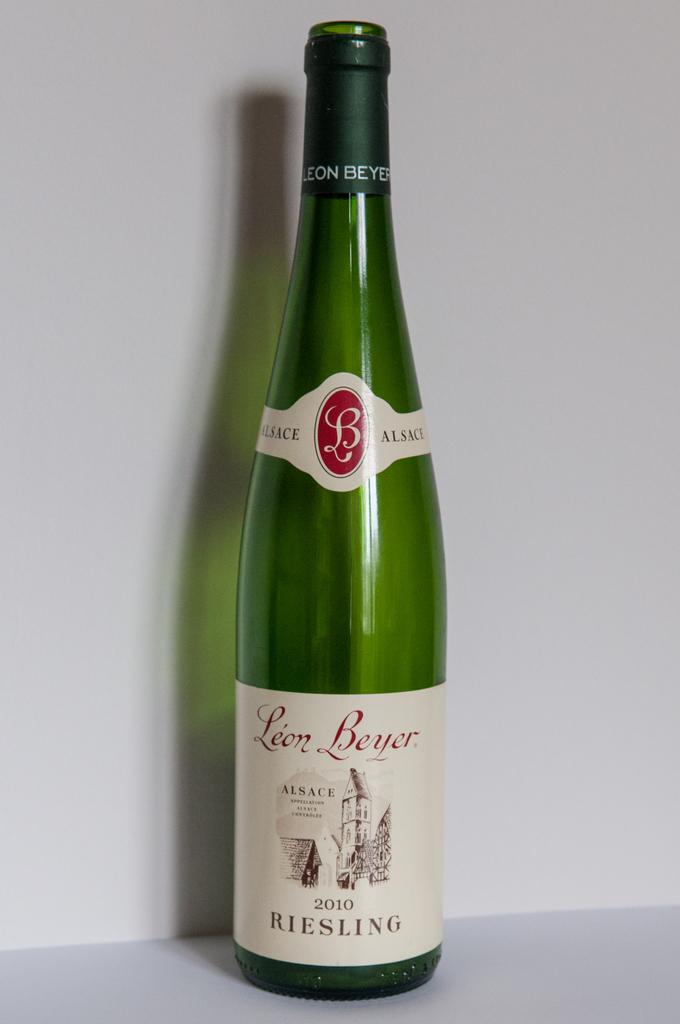Which country was that wine made in?
Keep it short and to the point. Unanswerable. 